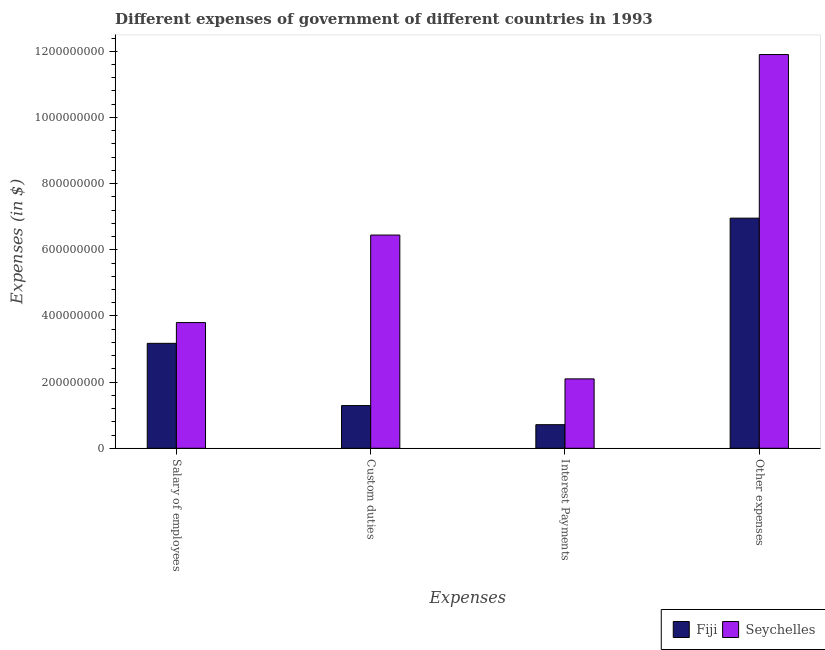How many different coloured bars are there?
Provide a succinct answer. 2. How many groups of bars are there?
Offer a terse response. 4. Are the number of bars on each tick of the X-axis equal?
Offer a terse response. Yes. What is the label of the 3rd group of bars from the left?
Your response must be concise. Interest Payments. What is the amount spent on custom duties in Fiji?
Ensure brevity in your answer.  1.29e+08. Across all countries, what is the maximum amount spent on other expenses?
Offer a terse response. 1.19e+09. Across all countries, what is the minimum amount spent on interest payments?
Provide a succinct answer. 7.14e+07. In which country was the amount spent on salary of employees maximum?
Give a very brief answer. Seychelles. In which country was the amount spent on interest payments minimum?
Give a very brief answer. Fiji. What is the total amount spent on custom duties in the graph?
Make the answer very short. 7.74e+08. What is the difference between the amount spent on interest payments in Fiji and that in Seychelles?
Offer a terse response. -1.38e+08. What is the difference between the amount spent on salary of employees in Seychelles and the amount spent on custom duties in Fiji?
Provide a succinct answer. 2.51e+08. What is the average amount spent on other expenses per country?
Provide a short and direct response. 9.43e+08. What is the difference between the amount spent on salary of employees and amount spent on other expenses in Fiji?
Offer a terse response. -3.78e+08. What is the ratio of the amount spent on other expenses in Fiji to that in Seychelles?
Ensure brevity in your answer.  0.58. Is the amount spent on interest payments in Seychelles less than that in Fiji?
Your answer should be very brief. No. Is the difference between the amount spent on other expenses in Fiji and Seychelles greater than the difference between the amount spent on interest payments in Fiji and Seychelles?
Your answer should be compact. No. What is the difference between the highest and the second highest amount spent on other expenses?
Keep it short and to the point. 4.94e+08. What is the difference between the highest and the lowest amount spent on other expenses?
Offer a terse response. 4.94e+08. Is it the case that in every country, the sum of the amount spent on other expenses and amount spent on custom duties is greater than the sum of amount spent on interest payments and amount spent on salary of employees?
Provide a short and direct response. Yes. What does the 1st bar from the left in Custom duties represents?
Your response must be concise. Fiji. What does the 1st bar from the right in Interest Payments represents?
Provide a succinct answer. Seychelles. Does the graph contain any zero values?
Your answer should be very brief. No. How many legend labels are there?
Offer a very short reply. 2. What is the title of the graph?
Your answer should be compact. Different expenses of government of different countries in 1993. What is the label or title of the X-axis?
Your response must be concise. Expenses. What is the label or title of the Y-axis?
Your answer should be compact. Expenses (in $). What is the Expenses (in $) in Fiji in Salary of employees?
Provide a succinct answer. 3.17e+08. What is the Expenses (in $) of Seychelles in Salary of employees?
Your response must be concise. 3.80e+08. What is the Expenses (in $) of Fiji in Custom duties?
Your answer should be very brief. 1.29e+08. What is the Expenses (in $) in Seychelles in Custom duties?
Your answer should be very brief. 6.44e+08. What is the Expenses (in $) of Fiji in Interest Payments?
Offer a very short reply. 7.14e+07. What is the Expenses (in $) of Seychelles in Interest Payments?
Keep it short and to the point. 2.10e+08. What is the Expenses (in $) of Fiji in Other expenses?
Give a very brief answer. 6.96e+08. What is the Expenses (in $) of Seychelles in Other expenses?
Offer a terse response. 1.19e+09. Across all Expenses, what is the maximum Expenses (in $) of Fiji?
Provide a succinct answer. 6.96e+08. Across all Expenses, what is the maximum Expenses (in $) of Seychelles?
Your answer should be compact. 1.19e+09. Across all Expenses, what is the minimum Expenses (in $) in Fiji?
Provide a short and direct response. 7.14e+07. Across all Expenses, what is the minimum Expenses (in $) of Seychelles?
Offer a terse response. 2.10e+08. What is the total Expenses (in $) in Fiji in the graph?
Your answer should be compact. 1.21e+09. What is the total Expenses (in $) in Seychelles in the graph?
Your answer should be very brief. 2.42e+09. What is the difference between the Expenses (in $) in Fiji in Salary of employees and that in Custom duties?
Your answer should be compact. 1.88e+08. What is the difference between the Expenses (in $) in Seychelles in Salary of employees and that in Custom duties?
Give a very brief answer. -2.64e+08. What is the difference between the Expenses (in $) of Fiji in Salary of employees and that in Interest Payments?
Ensure brevity in your answer.  2.46e+08. What is the difference between the Expenses (in $) in Seychelles in Salary of employees and that in Interest Payments?
Ensure brevity in your answer.  1.70e+08. What is the difference between the Expenses (in $) of Fiji in Salary of employees and that in Other expenses?
Provide a succinct answer. -3.78e+08. What is the difference between the Expenses (in $) of Seychelles in Salary of employees and that in Other expenses?
Your answer should be very brief. -8.10e+08. What is the difference between the Expenses (in $) of Fiji in Custom duties and that in Interest Payments?
Keep it short and to the point. 5.78e+07. What is the difference between the Expenses (in $) of Seychelles in Custom duties and that in Interest Payments?
Give a very brief answer. 4.35e+08. What is the difference between the Expenses (in $) in Fiji in Custom duties and that in Other expenses?
Make the answer very short. -5.67e+08. What is the difference between the Expenses (in $) in Seychelles in Custom duties and that in Other expenses?
Make the answer very short. -5.46e+08. What is the difference between the Expenses (in $) of Fiji in Interest Payments and that in Other expenses?
Your response must be concise. -6.24e+08. What is the difference between the Expenses (in $) in Seychelles in Interest Payments and that in Other expenses?
Your answer should be compact. -9.80e+08. What is the difference between the Expenses (in $) in Fiji in Salary of employees and the Expenses (in $) in Seychelles in Custom duties?
Provide a succinct answer. -3.27e+08. What is the difference between the Expenses (in $) in Fiji in Salary of employees and the Expenses (in $) in Seychelles in Interest Payments?
Ensure brevity in your answer.  1.07e+08. What is the difference between the Expenses (in $) in Fiji in Salary of employees and the Expenses (in $) in Seychelles in Other expenses?
Your response must be concise. -8.73e+08. What is the difference between the Expenses (in $) in Fiji in Custom duties and the Expenses (in $) in Seychelles in Interest Payments?
Offer a very short reply. -8.07e+07. What is the difference between the Expenses (in $) of Fiji in Custom duties and the Expenses (in $) of Seychelles in Other expenses?
Your answer should be very brief. -1.06e+09. What is the difference between the Expenses (in $) in Fiji in Interest Payments and the Expenses (in $) in Seychelles in Other expenses?
Your answer should be very brief. -1.12e+09. What is the average Expenses (in $) in Fiji per Expenses?
Provide a short and direct response. 3.03e+08. What is the average Expenses (in $) in Seychelles per Expenses?
Keep it short and to the point. 6.06e+08. What is the difference between the Expenses (in $) of Fiji and Expenses (in $) of Seychelles in Salary of employees?
Provide a succinct answer. -6.28e+07. What is the difference between the Expenses (in $) in Fiji and Expenses (in $) in Seychelles in Custom duties?
Ensure brevity in your answer.  -5.15e+08. What is the difference between the Expenses (in $) in Fiji and Expenses (in $) in Seychelles in Interest Payments?
Provide a succinct answer. -1.38e+08. What is the difference between the Expenses (in $) of Fiji and Expenses (in $) of Seychelles in Other expenses?
Give a very brief answer. -4.94e+08. What is the ratio of the Expenses (in $) of Fiji in Salary of employees to that in Custom duties?
Offer a very short reply. 2.46. What is the ratio of the Expenses (in $) of Seychelles in Salary of employees to that in Custom duties?
Keep it short and to the point. 0.59. What is the ratio of the Expenses (in $) of Fiji in Salary of employees to that in Interest Payments?
Provide a short and direct response. 4.45. What is the ratio of the Expenses (in $) in Seychelles in Salary of employees to that in Interest Payments?
Offer a very short reply. 1.81. What is the ratio of the Expenses (in $) of Fiji in Salary of employees to that in Other expenses?
Your answer should be compact. 0.46. What is the ratio of the Expenses (in $) in Seychelles in Salary of employees to that in Other expenses?
Give a very brief answer. 0.32. What is the ratio of the Expenses (in $) in Fiji in Custom duties to that in Interest Payments?
Make the answer very short. 1.81. What is the ratio of the Expenses (in $) in Seychelles in Custom duties to that in Interest Payments?
Make the answer very short. 3.07. What is the ratio of the Expenses (in $) of Fiji in Custom duties to that in Other expenses?
Provide a short and direct response. 0.19. What is the ratio of the Expenses (in $) in Seychelles in Custom duties to that in Other expenses?
Your answer should be very brief. 0.54. What is the ratio of the Expenses (in $) of Fiji in Interest Payments to that in Other expenses?
Provide a short and direct response. 0.1. What is the ratio of the Expenses (in $) of Seychelles in Interest Payments to that in Other expenses?
Provide a short and direct response. 0.18. What is the difference between the highest and the second highest Expenses (in $) of Fiji?
Keep it short and to the point. 3.78e+08. What is the difference between the highest and the second highest Expenses (in $) in Seychelles?
Ensure brevity in your answer.  5.46e+08. What is the difference between the highest and the lowest Expenses (in $) of Fiji?
Ensure brevity in your answer.  6.24e+08. What is the difference between the highest and the lowest Expenses (in $) of Seychelles?
Your answer should be compact. 9.80e+08. 